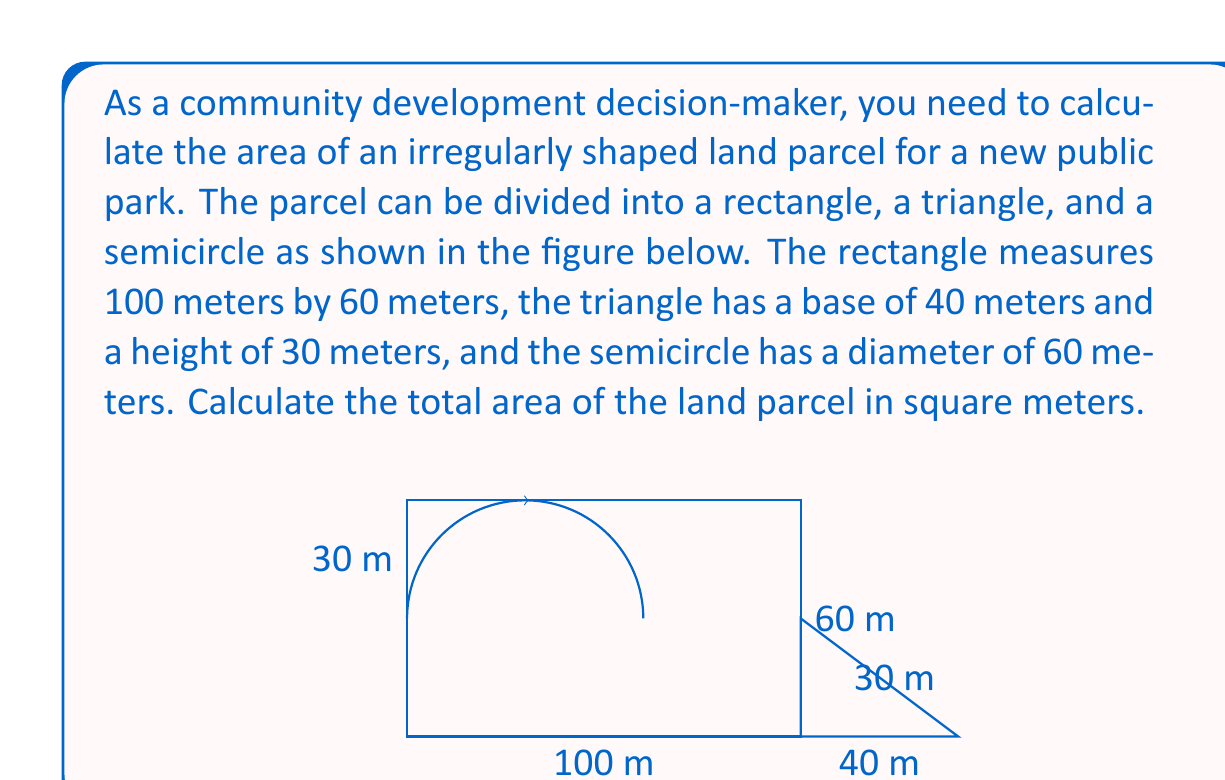Can you solve this math problem? To calculate the total area of the irregularly shaped land parcel, we need to sum the areas of its component shapes:

1. Area of the rectangle:
   $A_r = l \times w = 100 \text{ m} \times 60 \text{ m} = 6000 \text{ m}^2$

2. Area of the triangle:
   $A_t = \frac{1}{2} \times b \times h = \frac{1}{2} \times 40 \text{ m} \times 30 \text{ m} = 600 \text{ m}^2$

3. Area of the semicircle:
   Radius of the semicircle: $r = 30 \text{ m}$
   $A_s = \frac{1}{2} \times \pi r^2 = \frac{1}{2} \times \pi \times (30 \text{ m})^2 = 1413.72 \text{ m}^2$

Now, we sum up all the areas:

$A_{\text{total}} = A_r + A_t + A_s$
$A_{\text{total}} = 6000 \text{ m}^2 + 600 \text{ m}^2 + 1413.72 \text{ m}^2$
$A_{\text{total}} = 8013.72 \text{ m}^2$

Therefore, the total area of the irregularly shaped land parcel is approximately 8013.72 square meters.
Answer: 8013.72 m² 